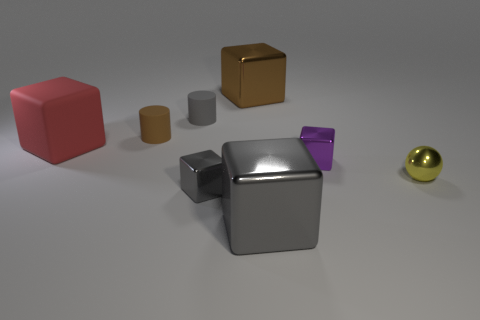Subtract all tiny metal blocks. How many blocks are left? 3 Subtract 1 spheres. How many spheres are left? 0 Add 1 large brown metal cubes. How many objects exist? 9 Subtract all gray balls. How many gray cubes are left? 2 Subtract all gray blocks. How many blocks are left? 3 Subtract all balls. How many objects are left? 7 Subtract all red spheres. Subtract all yellow cylinders. How many spheres are left? 1 Subtract all tiny yellow balls. Subtract all small yellow metal spheres. How many objects are left? 6 Add 6 big shiny objects. How many big shiny objects are left? 8 Add 6 tiny cyan metal objects. How many tiny cyan metal objects exist? 6 